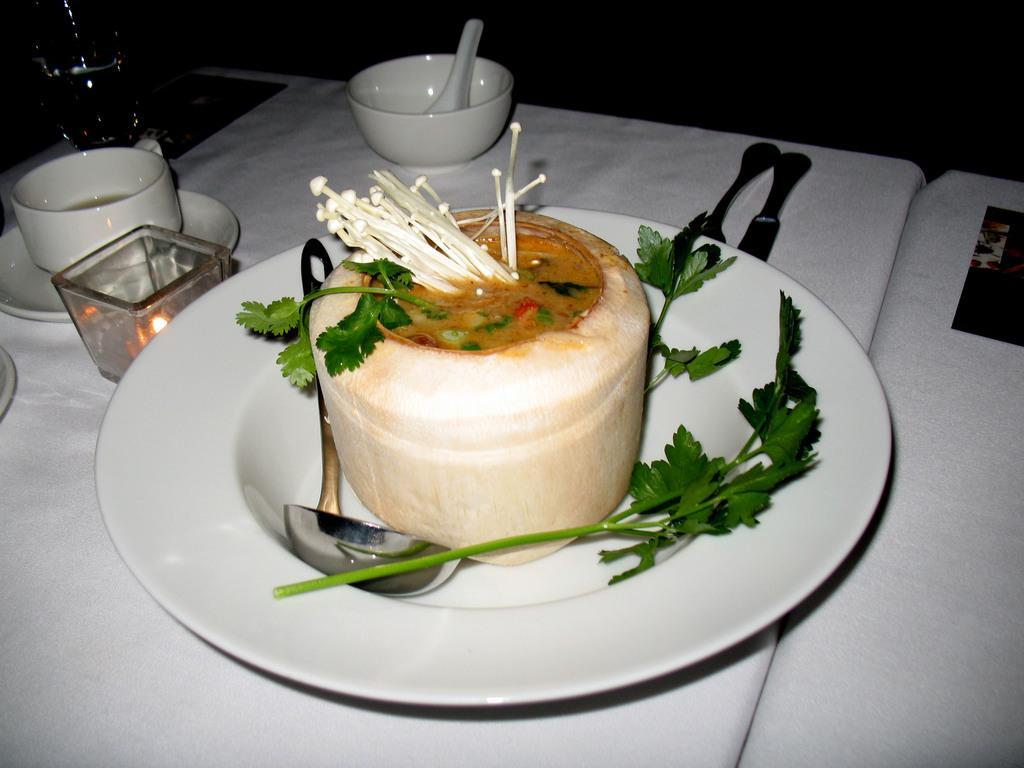Can you describe this image briefly? This image consists of a plate in the middle. It is in white color. In that there is a spoon, leafy vegetables, and some eatables. There is bowl at the top and left side. There is a candle on the left side. There is a water bottle in the top left corner. There are fork and knife in the middle. 